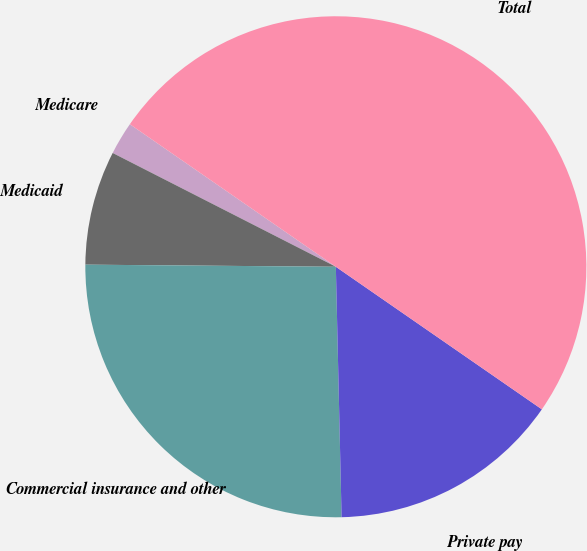Convert chart. <chart><loc_0><loc_0><loc_500><loc_500><pie_chart><fcel>Medicare<fcel>Medicaid<fcel>Commercial insurance and other<fcel>Private pay<fcel>Total<nl><fcel>2.13%<fcel>7.37%<fcel>25.5%<fcel>15.0%<fcel>50.0%<nl></chart> 